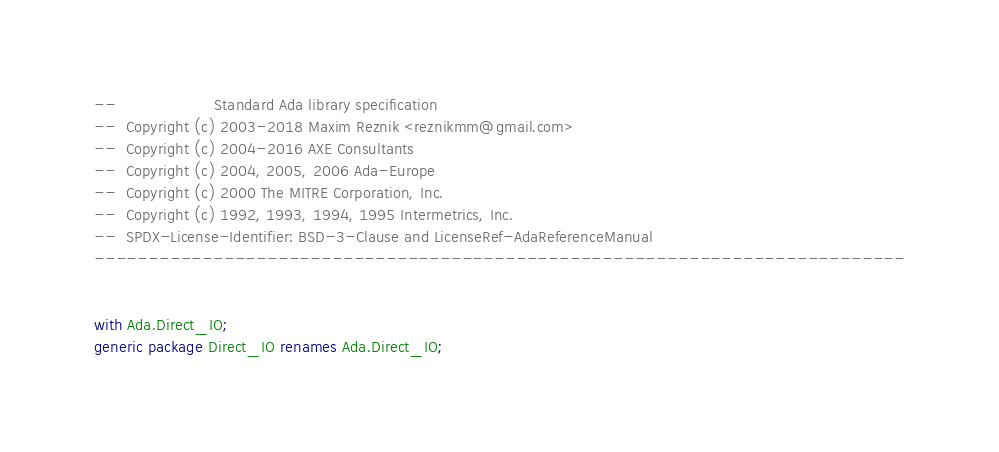<code> <loc_0><loc_0><loc_500><loc_500><_Ada_>--                    Standard Ada library specification
--  Copyright (c) 2003-2018 Maxim Reznik <reznikmm@gmail.com>
--  Copyright (c) 2004-2016 AXE Consultants
--  Copyright (c) 2004, 2005, 2006 Ada-Europe
--  Copyright (c) 2000 The MITRE Corporation, Inc.
--  Copyright (c) 1992, 1993, 1994, 1995 Intermetrics, Inc.
--  SPDX-License-Identifier: BSD-3-Clause and LicenseRef-AdaReferenceManual
---------------------------------------------------------------------------


with Ada.Direct_IO;
generic package Direct_IO renames Ada.Direct_IO;
</code> 